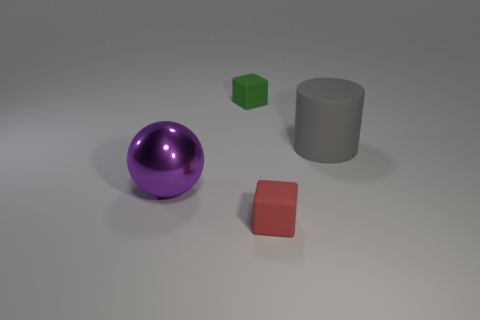Does the lighting have an impact on the colors of the objects? Yes, lighting can significantly affect the perception of colors. In this image, the lighting appears soft and diffused, creating subtle shadows. This allows the inherent colors of the purple sphere, green cube, and red square to remain vibrant and distinct without harsh reflections or deep shadows that might alter their appearance. 